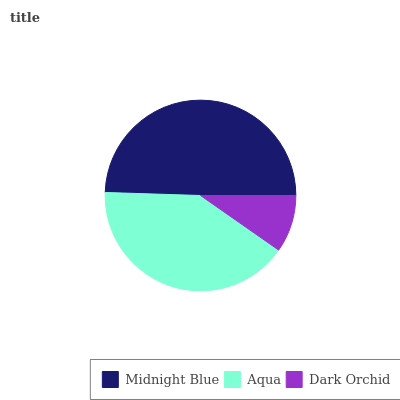Is Dark Orchid the minimum?
Answer yes or no. Yes. Is Midnight Blue the maximum?
Answer yes or no. Yes. Is Aqua the minimum?
Answer yes or no. No. Is Aqua the maximum?
Answer yes or no. No. Is Midnight Blue greater than Aqua?
Answer yes or no. Yes. Is Aqua less than Midnight Blue?
Answer yes or no. Yes. Is Aqua greater than Midnight Blue?
Answer yes or no. No. Is Midnight Blue less than Aqua?
Answer yes or no. No. Is Aqua the high median?
Answer yes or no. Yes. Is Aqua the low median?
Answer yes or no. Yes. Is Midnight Blue the high median?
Answer yes or no. No. Is Midnight Blue the low median?
Answer yes or no. No. 